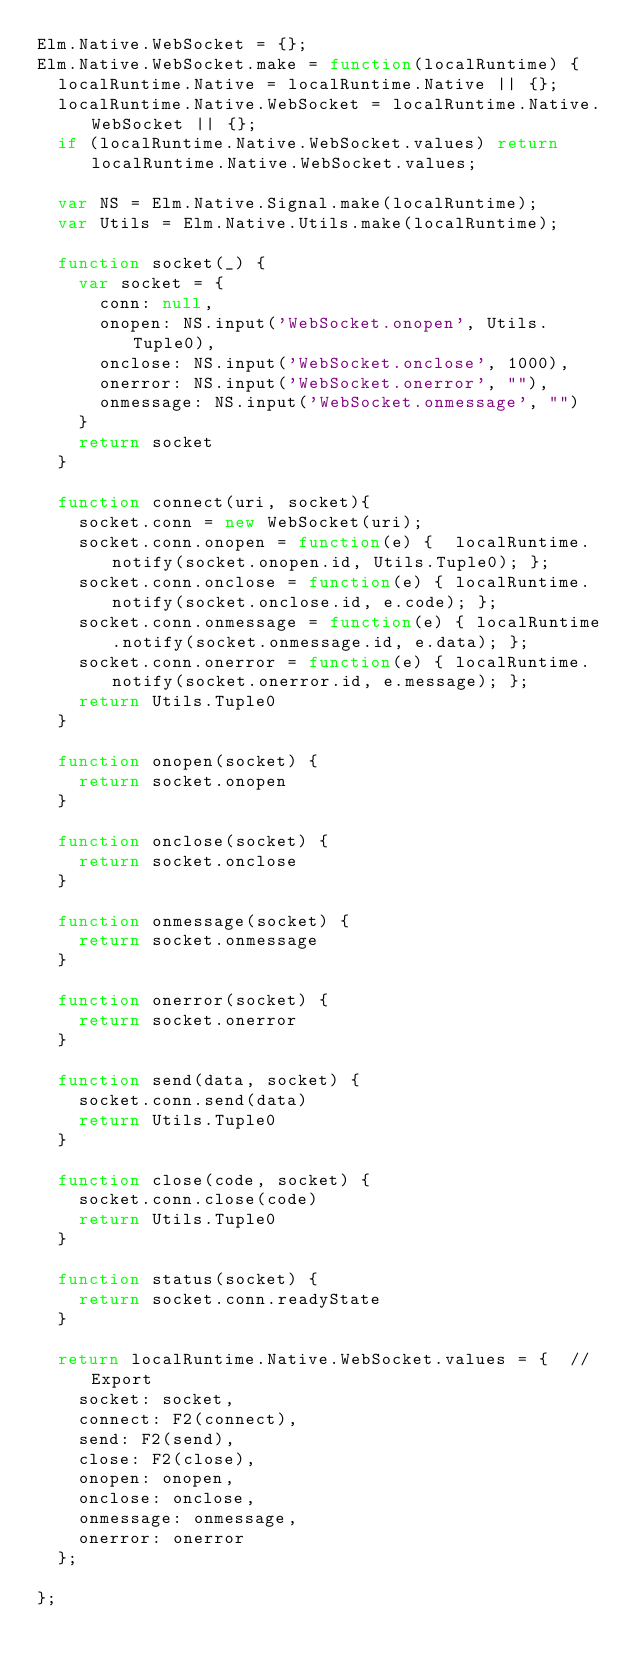Convert code to text. <code><loc_0><loc_0><loc_500><loc_500><_JavaScript_>Elm.Native.WebSocket = {};
Elm.Native.WebSocket.make = function(localRuntime) {
  localRuntime.Native = localRuntime.Native || {};
  localRuntime.Native.WebSocket = localRuntime.Native.WebSocket || {};
  if (localRuntime.Native.WebSocket.values) return localRuntime.Native.WebSocket.values;

	var NS = Elm.Native.Signal.make(localRuntime);
	var Utils = Elm.Native.Utils.make(localRuntime);

  function socket(_) {
    var socket = {
      conn: null,
      onopen: NS.input('WebSocket.onopen', Utils.Tuple0),
      onclose: NS.input('WebSocket.onclose', 1000),
      onerror: NS.input('WebSocket.onerror', ""),
      onmessage: NS.input('WebSocket.onmessage', "")
    }
    return socket
  }

  function connect(uri, socket){
    socket.conn = new WebSocket(uri);
    socket.conn.onopen = function(e) {  localRuntime.notify(socket.onopen.id, Utils.Tuple0); };
    socket.conn.onclose = function(e) { localRuntime.notify(socket.onclose.id, e.code); };
    socket.conn.onmessage = function(e) { localRuntime.notify(socket.onmessage.id, e.data); };
    socket.conn.onerror = function(e) { localRuntime.notify(socket.onerror.id, e.message); };
    return Utils.Tuple0
  }

  function onopen(socket) {
    return socket.onopen
  }

  function onclose(socket) {
    return socket.onclose
  }

  function onmessage(socket) {
    return socket.onmessage
  }

  function onerror(socket) {
    return socket.onerror
  }

  function send(data, socket) {
    socket.conn.send(data)
    return Utils.Tuple0
  }

  function close(code, socket) {
    socket.conn.close(code)
    return Utils.Tuple0
  }

  function status(socket) {
    return socket.conn.readyState
  }

  return localRuntime.Native.WebSocket.values = {  // Export
    socket: socket,
    connect: F2(connect),
    send: F2(send),
    close: F2(close),
    onopen: onopen,
    onclose: onclose,
    onmessage: onmessage,
    onerror: onerror
  };

};
</code> 